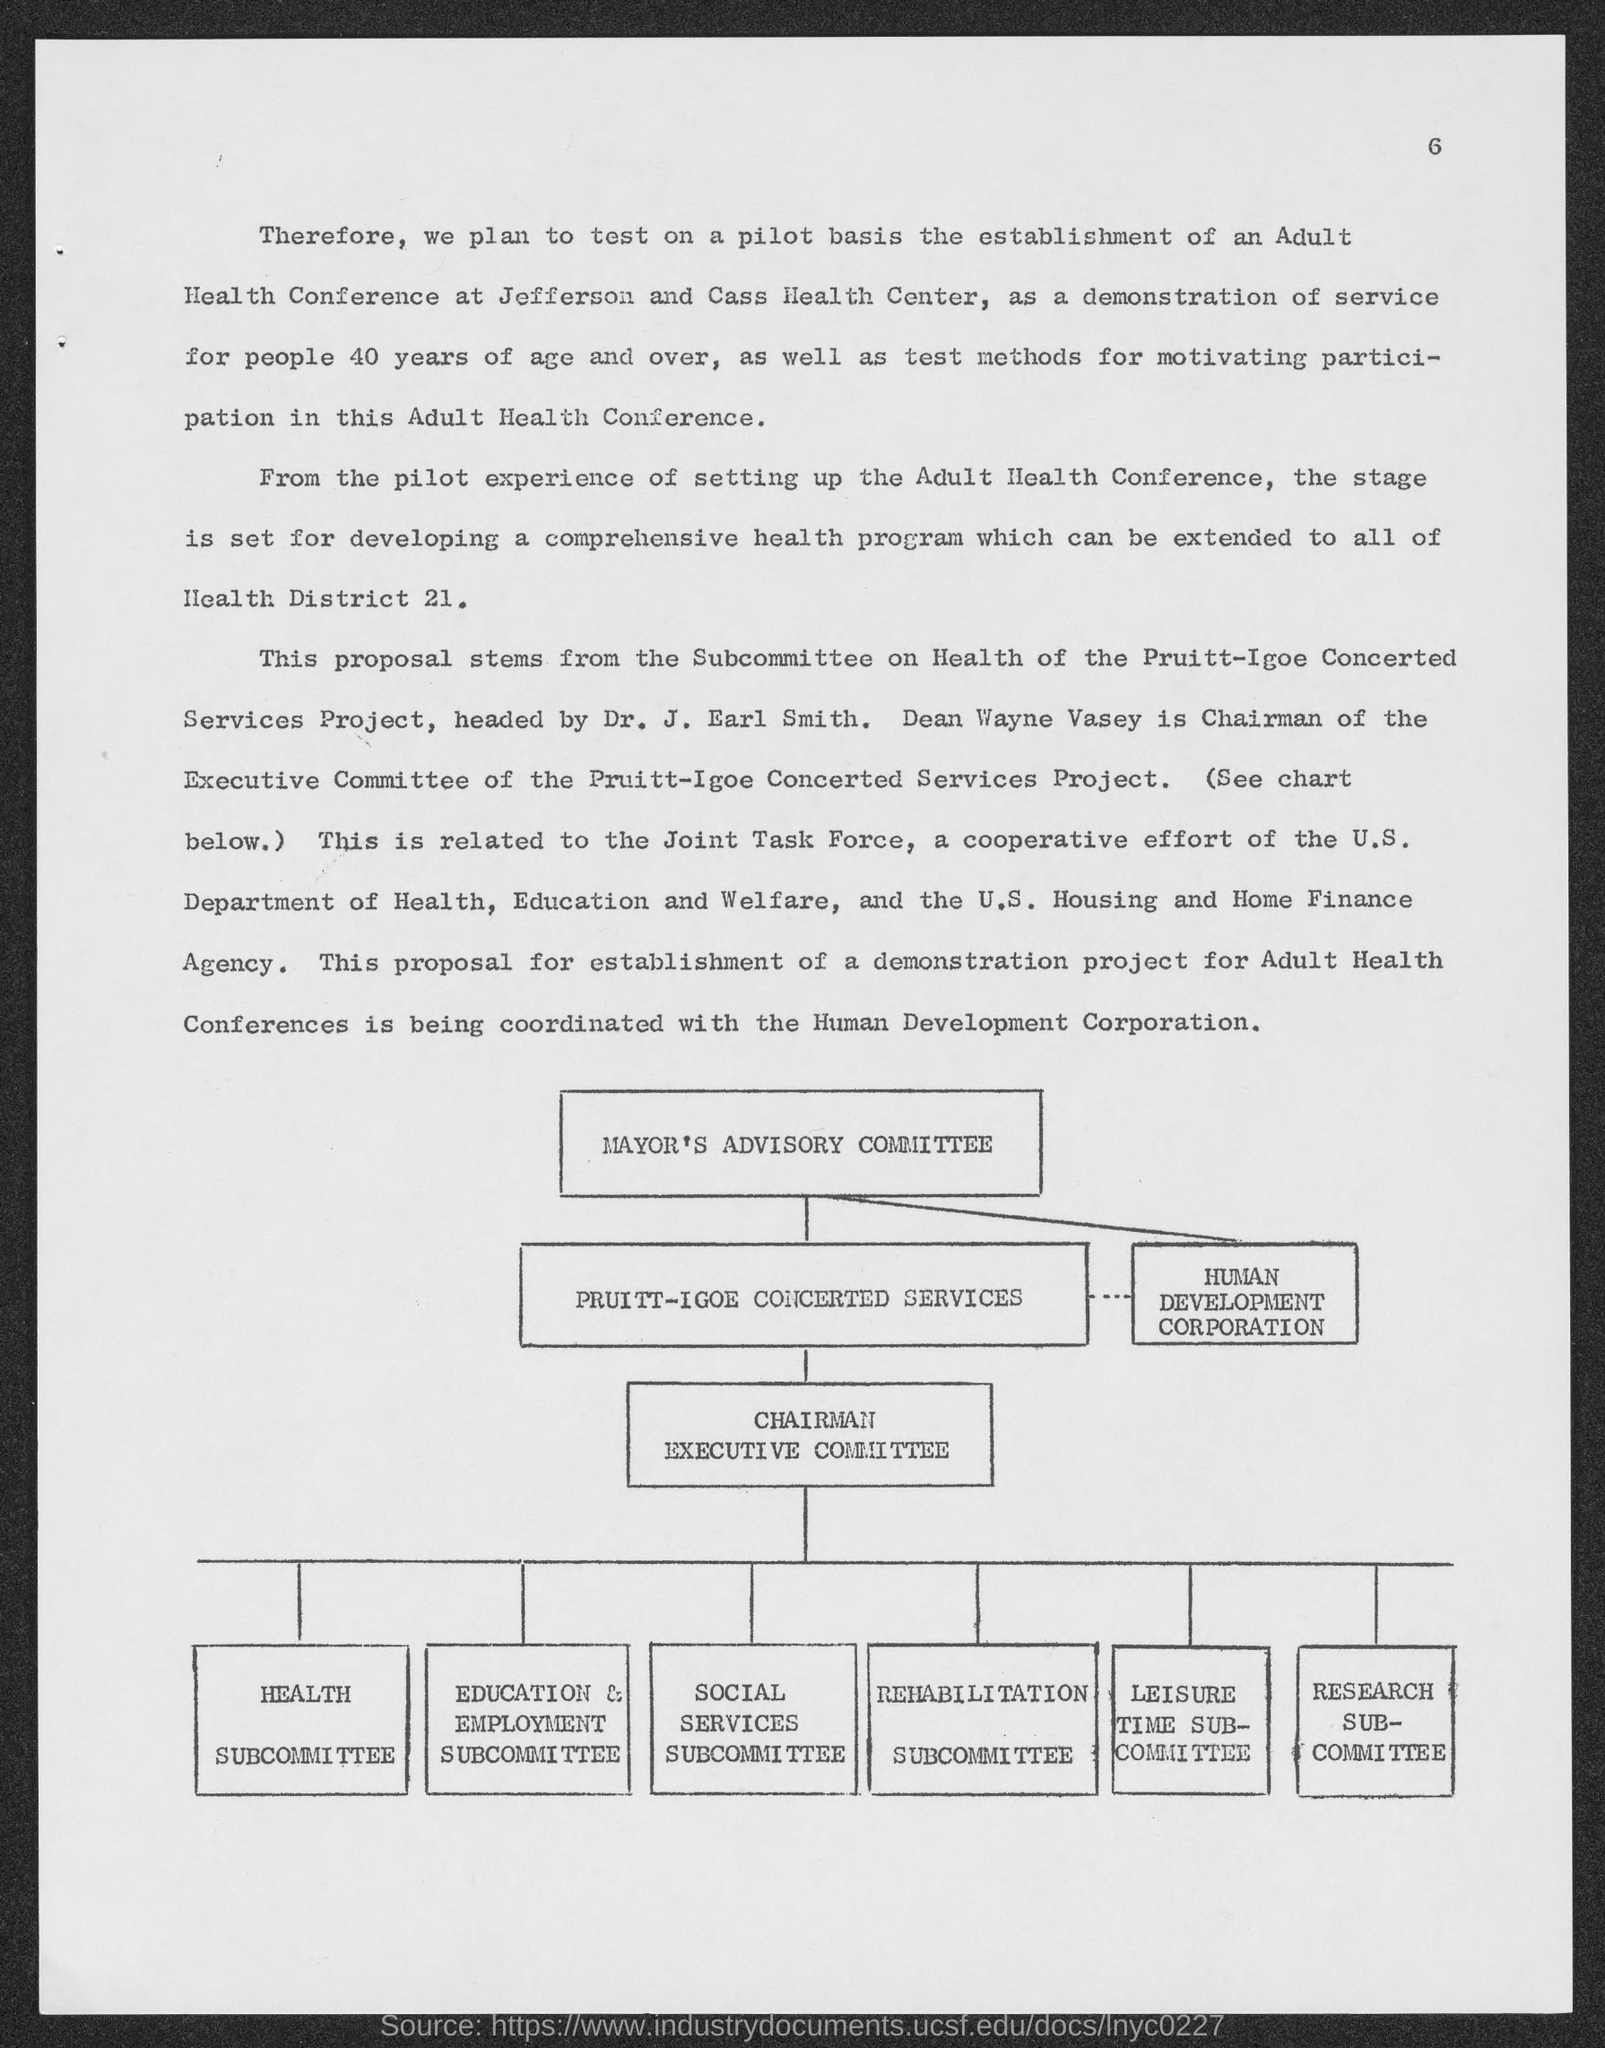Indicate a few pertinent items in this graphic. The Chairman of the Executive Committee of the Pruitt-Igoe Concerted Services Project is Dean Wayne Vasey. The document mentions page number 6.. 